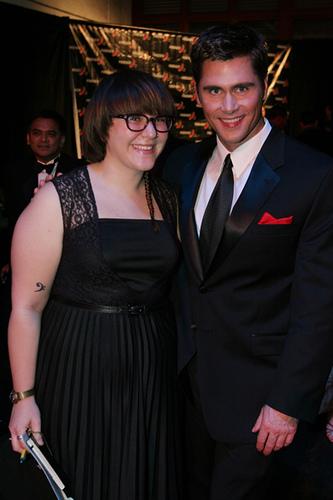Is this a happy couple?
Be succinct. Yes. What is in his jacket's left pocket?
Give a very brief answer. Handkerchief. Is the woman wearing a necklace?
Write a very short answer. No. What color is the suit on the right?
Be succinct. Black. 